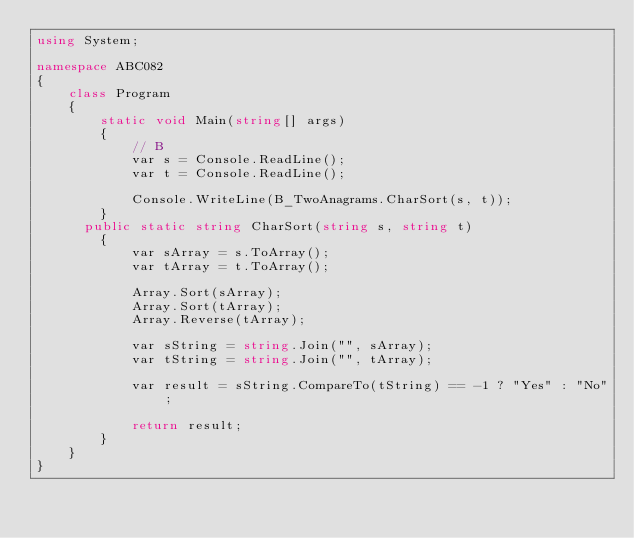<code> <loc_0><loc_0><loc_500><loc_500><_C#_>using System;

namespace ABC082
{
    class Program
    {
        static void Main(string[] args)
        {
            // B
            var s = Console.ReadLine();
            var t = Console.ReadLine();

            Console.WriteLine(B_TwoAnagrams.CharSort(s, t));
        }
      public static string CharSort(string s, string t)
        {
            var sArray = s.ToArray();
            var tArray = t.ToArray();

            Array.Sort(sArray);
            Array.Sort(tArray);
            Array.Reverse(tArray);

            var sString = string.Join("", sArray);
            var tString = string.Join("", tArray);

            var result = sString.CompareTo(tString) == -1 ? "Yes" : "No";

            return result;
        }
    }
}</code> 